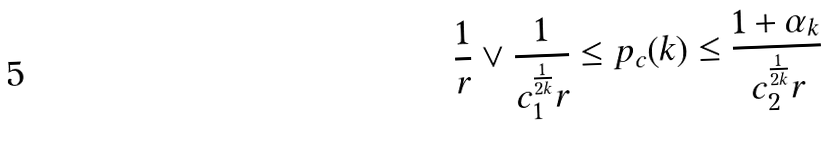Convert formula to latex. <formula><loc_0><loc_0><loc_500><loc_500>\frac { 1 } { r } \vee \frac { 1 } { c _ { 1 } ^ { \frac { 1 } { 2 k } } r } \leq p _ { c } ( k ) \leq \frac { 1 + \alpha _ { k } } { c _ { 2 } ^ { \frac { 1 } { 2 k } } r }</formula> 